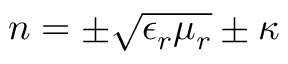Convert formula to latex. <formula><loc_0><loc_0><loc_500><loc_500>n = \pm { \sqrt { \epsilon _ { r } \mu _ { r } } } \pm \kappa</formula> 